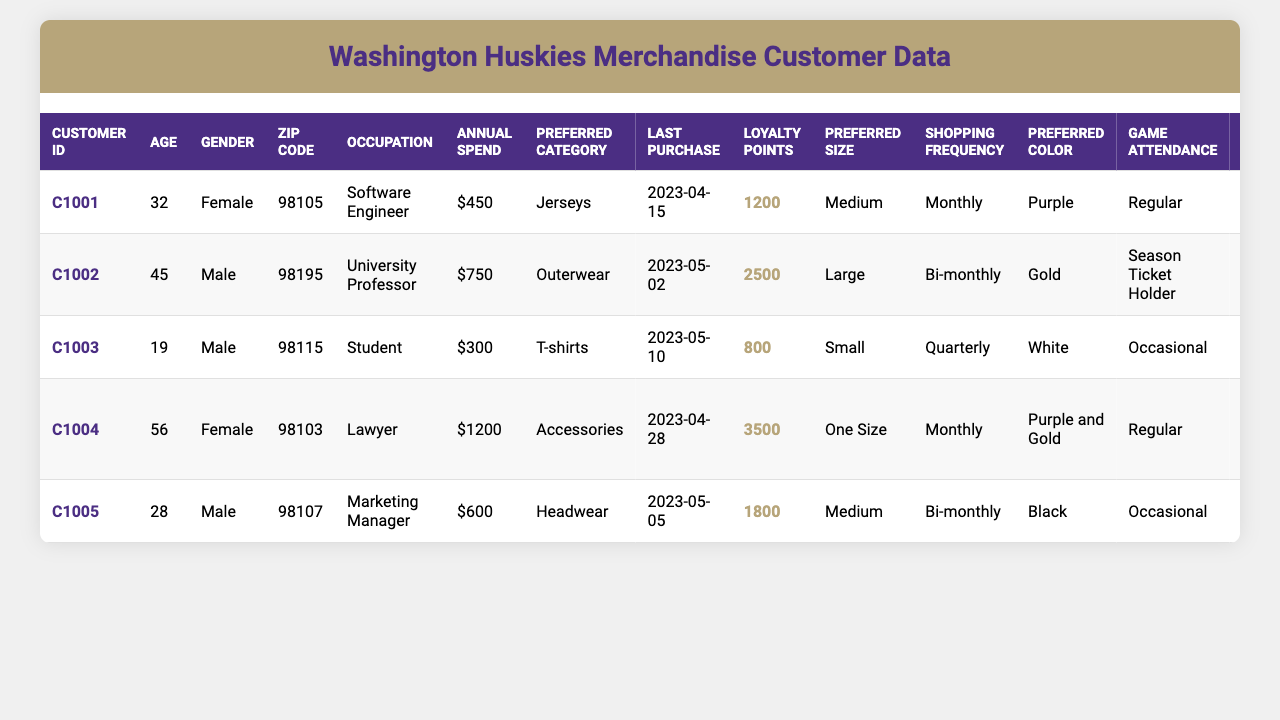What is the age of the customer with ID C1003? Referring to the table, customer C1003 has the age listed as 19.
Answer: 19 How much does the customer with the highest annual spend spend? By examining the "Annual Spend" column, customer C1004 spends the highest amount: $1200.
Answer: $1200 Who is the only customer that prefers T-shirts? Looking at the "Preferred Category" column, customer C1003 is the only one who has T-shirts listed as their preference.
Answer: C1003 What is the preferred color of the customer who is a Lawyer? Checking the occupation, customer C1004, who is a Lawyer, has "Purple and Gold" listed as their preferred color.
Answer: Purple and Gold Which customer has the most loyalty points? By comparing the "Loyalty Points" column, customer C1004 has the highest points with a total of 3500.
Answer: C1004 How frequently does the customer with the least annual spend make purchases? Customer C1003 has the least annual spend of $300, and their shopping frequency is noted as quarterly.
Answer: Quarterly Do any customers have "online only" as their shopping method? Yes, customer C1003 has "Online Only" listed under the "Shopping Method" column.
Answer: Yes What is the average annual spend of all customers? To find the average, sum the annual spends: (450 + 750 + 300 + 1200 + 600) = 3300. There are 5 customers, so the average is 3300/5 = 660.
Answer: $660 How many customers attend games regularly? Checking the "Game Attendance" column, both customers C1001 and C1004 are marked as attending games regularly, making a total of 2.
Answer: 2 Which gender has a higher overall spending based on the data? Customer C1004 and C1001 are female customers with spends of $1200 and $450 respectively, totaling $1650. Males C1002, C1003, and C1005 have spends of $750, $300, and $600, totaling $1650 as well. Both genders spend equally in this case.
Answer: Equal Which preferred category is most common among customers? Reviewing the "Preferred Category" column reveals: Jerseys (1), Outerwear (1), T-shirts (1), Accessories (1), and Headwear (1), meaning all categories are represented once, with no category being more common.
Answer: None What is the last purchase date of the customer with the highest loyalty points? Customer C1004 has the highest loyalty points at 3500, and their last purchase date is April 28, 2023.
Answer: April 28, 2023 How does the shopping frequency of males compare to females? Males C1002, C1003, and C1005 shop bi-monthly, quarterly, and mostly online. Females C1001 and C1004 shop monthly and monthly. Males are less frequent than females.
Answer: Males shop less frequently than females 